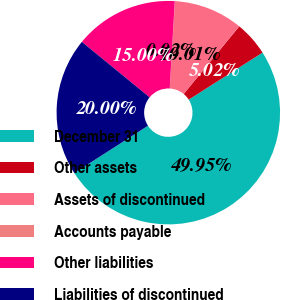Convert chart to OTSL. <chart><loc_0><loc_0><loc_500><loc_500><pie_chart><fcel>December 31<fcel>Other assets<fcel>Assets of discontinued<fcel>Accounts payable<fcel>Other liabilities<fcel>Liabilities of discontinued<nl><fcel>49.95%<fcel>5.02%<fcel>10.01%<fcel>0.02%<fcel>15.0%<fcel>20.0%<nl></chart> 